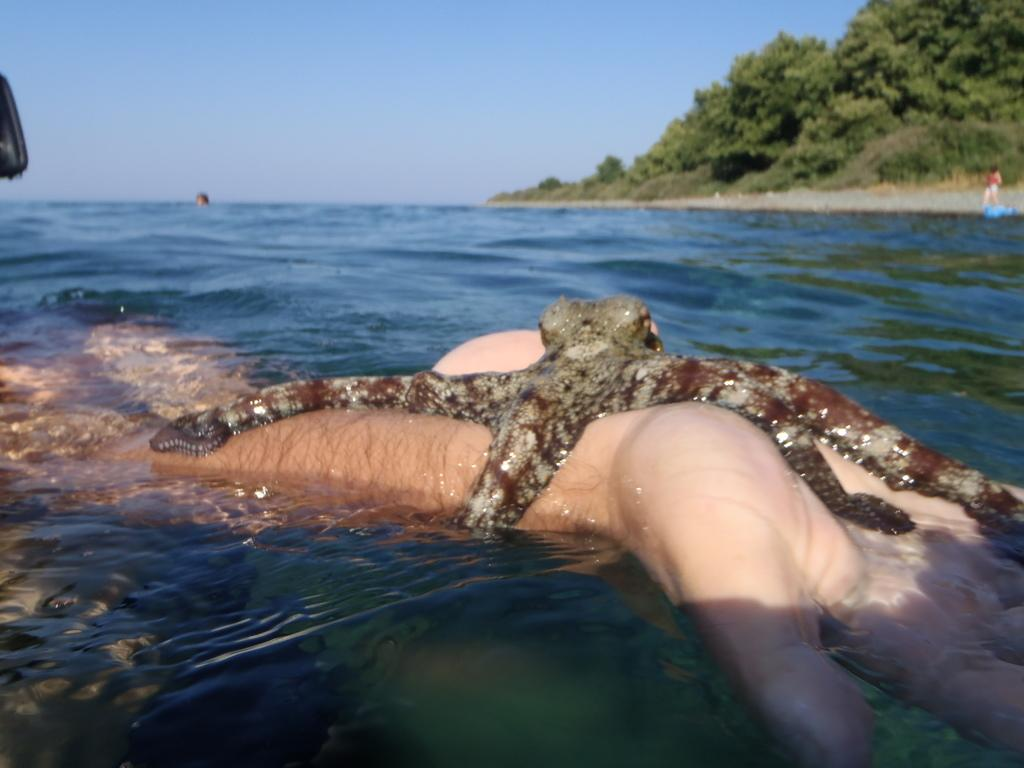What is on the hand in the image? There is an octopus on a hand in the image. What are the people in the image doing? The people in the image are in the water. What can be seen in the background of the image? There are trees visible in the background of the image. What type of thread is being used to sew the spot on the octopus's back in the image? There is no spot or thread present on the octopus in the image; it is an octopus on a hand. 